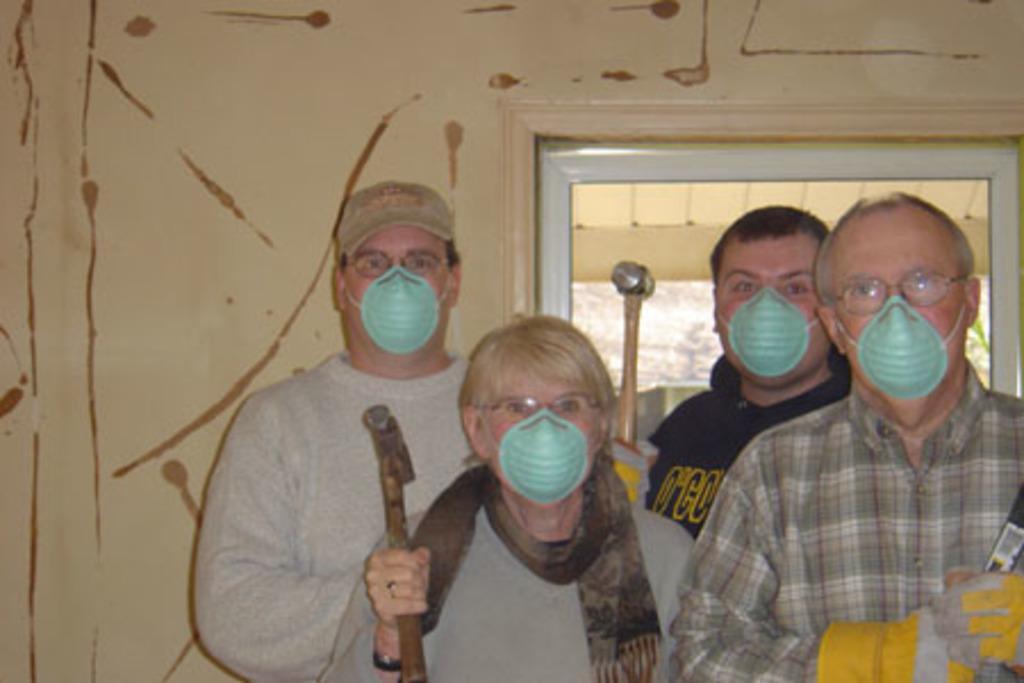Can you describe this image briefly? In this image there are four people standing. They are wearing masks and holding hammers in their hands. Behind them there is a wall. There is a door to the wall. 